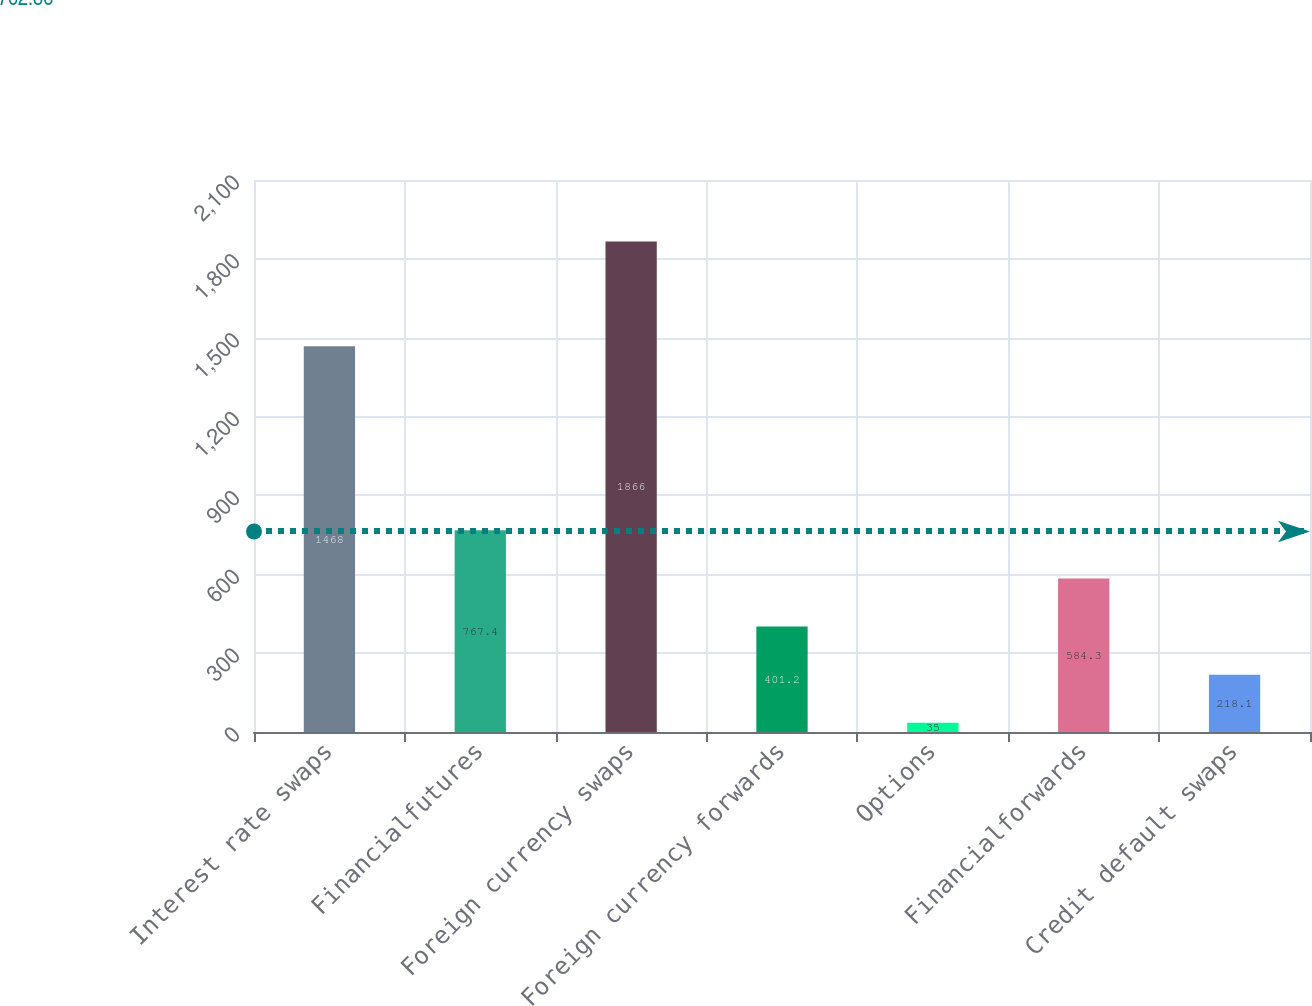<chart> <loc_0><loc_0><loc_500><loc_500><bar_chart><fcel>Interest rate swaps<fcel>Financialfutures<fcel>Foreign currency swaps<fcel>Foreign currency forwards<fcel>Options<fcel>Financialforwards<fcel>Credit default swaps<nl><fcel>1468<fcel>767.4<fcel>1866<fcel>401.2<fcel>35<fcel>584.3<fcel>218.1<nl></chart> 